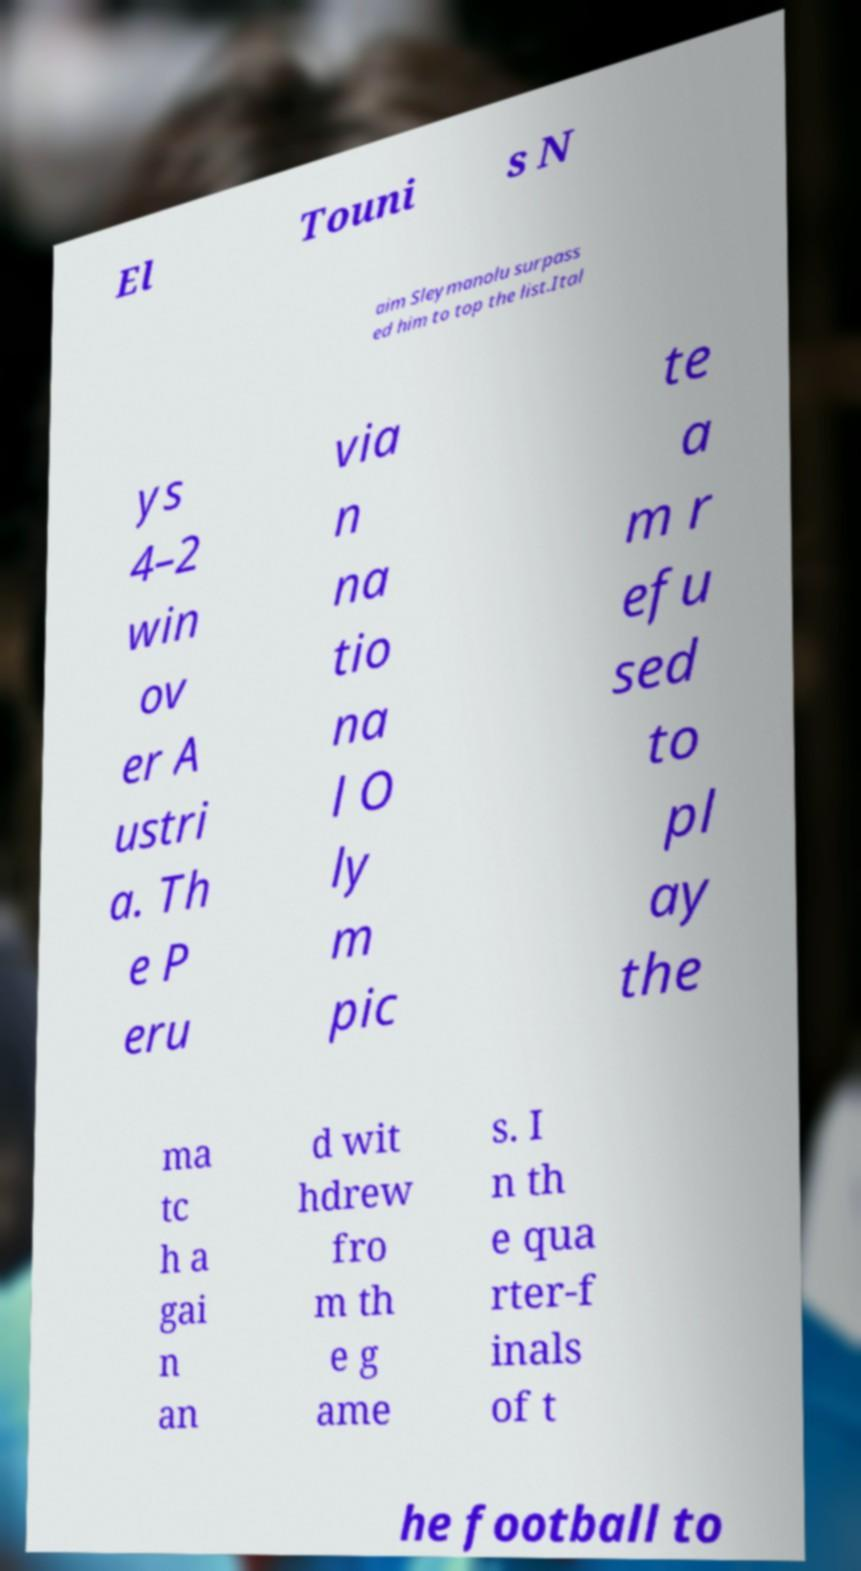There's text embedded in this image that I need extracted. Can you transcribe it verbatim? El Touni s N aim Sleymanolu surpass ed him to top the list.Ital ys 4–2 win ov er A ustri a. Th e P eru via n na tio na l O ly m pic te a m r efu sed to pl ay the ma tc h a gai n an d wit hdrew fro m th e g ame s. I n th e qua rter-f inals of t he football to 